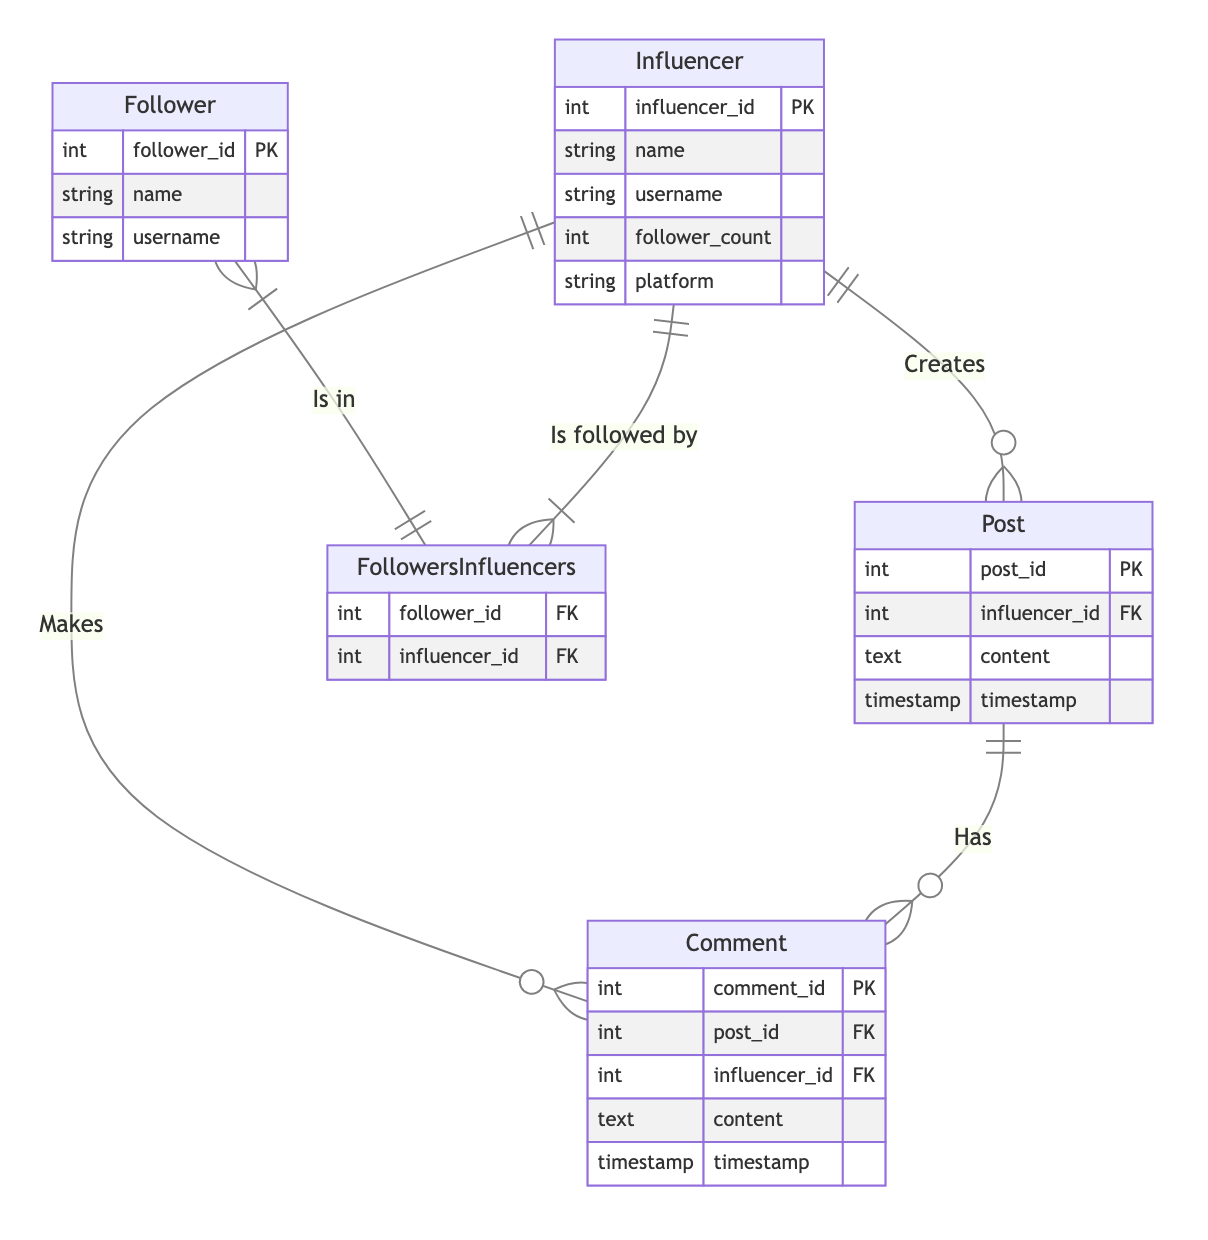What is the primary key of the Influencer entity? The primary key of the Influencer entity is "influencer_id," which uniquely identifies each influencer in the database.
Answer: influencer_id How many attributes are there in the Comment entity? The Comment entity has five attributes: comment_id, post_id, influencer_id, content, and timestamp.
Answer: five What type of relationship exists between Influencer and Post? The relationship between Influencer and Post is "One-to-Many," meaning one influencer can create multiple posts, but each post is created by a single influencer.
Answer: One-to-Many Which entity can be referenced in both Comments and FollowersInfluencers relationships? The Influencer entity can be referenced in both comments (through influencer_id) and followers (through the bridge table FollowersInfluencers).
Answer: Influencer How many foreign keys does the Post entity have? The Post entity has one foreign key, which is influencer_id, linking each post to the influencer who created it.
Answer: one What is the bridge entity between Follower and Influencer? The bridge entity that connects Follower and Influencer is called FollowersInfluencers, which establishes the many-to-many relationship between the two entities.
Answer: FollowersInfluencers What type of relationship is established between Post and Comment? The relationship established between Post and Comment is "One-to-Many," indicating each post can have many comments, while each comment relates to only one post.
Answer: One-to-Many How many primary keys exist across all entities? There are five primary keys, one in each of the entities: Influencer, Post, Comment, Follower, and FollowersInfluencers.
Answer: five Which entity has a follower_count attribute? The Influencer entity has a follower_count attribute, used to denote the number of followers an influencer has.
Answer: Influencer 